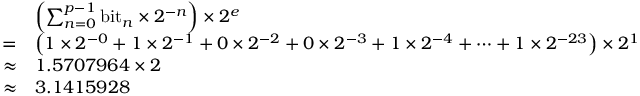Convert formula to latex. <formula><loc_0><loc_0><loc_500><loc_500>{ \begin{array} { r l } & { \left ( \sum _ { n = 0 } ^ { p - 1 } { b i t } _ { n } \times 2 ^ { - n } \right ) \times 2 ^ { e } } \\ { = } & { \left ( 1 \times 2 ^ { - 0 } + 1 \times 2 ^ { - 1 } + 0 \times 2 ^ { - 2 } + 0 \times 2 ^ { - 3 } + 1 \times 2 ^ { - 4 } + \cdots + 1 \times 2 ^ { - 2 3 } \right ) \times 2 ^ { 1 } } \\ { \approx } & { 1 . 5 7 0 7 9 6 4 \times 2 } \\ { \approx } & { 3 . 1 4 1 5 9 2 8 } \end{array} }</formula> 